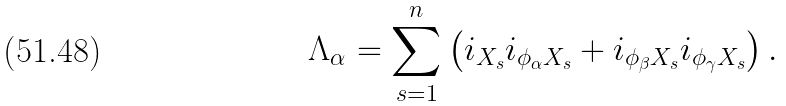<formula> <loc_0><loc_0><loc_500><loc_500>\Lambda _ { \alpha } = \sum _ { s = 1 } ^ { n } \left ( i _ { X _ { s } } i _ { \phi _ { \alpha } X _ { s } } + i _ { \phi _ { \beta } X _ { s } } i _ { \phi _ { \gamma } X _ { s } } \right ) .</formula> 